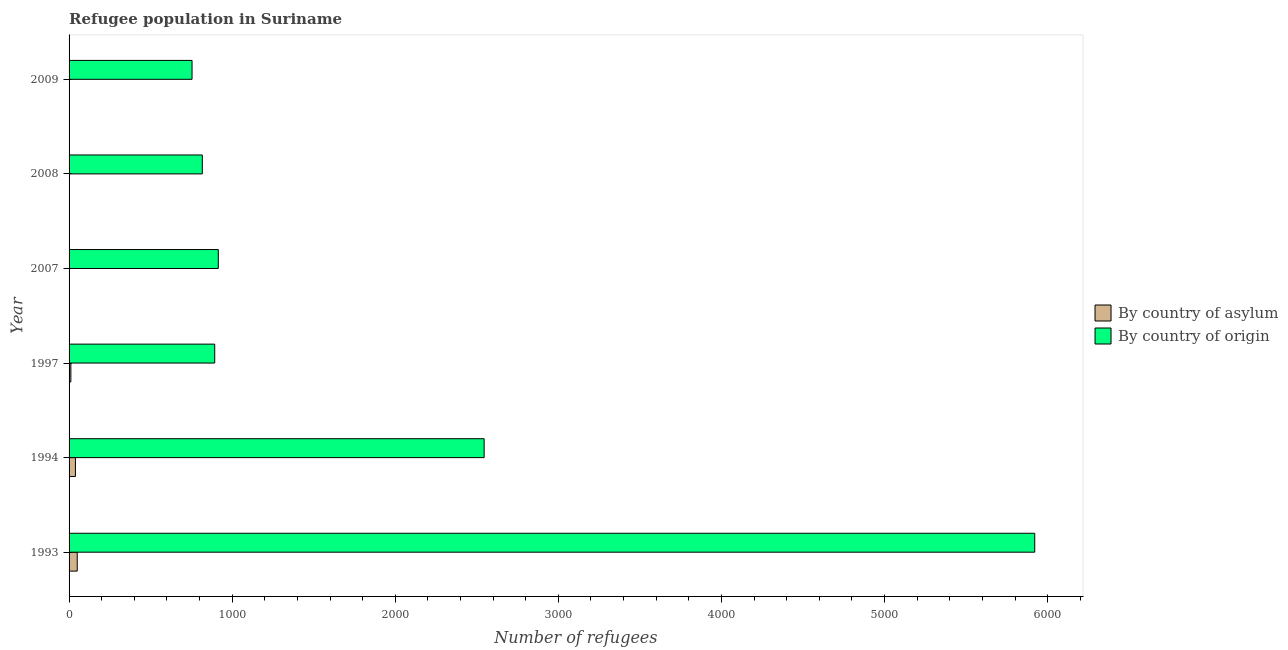Are the number of bars on each tick of the Y-axis equal?
Keep it short and to the point. Yes. How many bars are there on the 4th tick from the bottom?
Provide a short and direct response. 2. What is the label of the 1st group of bars from the top?
Keep it short and to the point. 2009. In how many cases, is the number of bars for a given year not equal to the number of legend labels?
Offer a very short reply. 0. What is the number of refugees by country of asylum in 2007?
Ensure brevity in your answer.  1. Across all years, what is the maximum number of refugees by country of origin?
Keep it short and to the point. 5921. Across all years, what is the minimum number of refugees by country of asylum?
Your answer should be very brief. 1. In which year was the number of refugees by country of asylum minimum?
Make the answer very short. 2007. What is the total number of refugees by country of asylum in the graph?
Your answer should be very brief. 103. What is the difference between the number of refugees by country of asylum in 2007 and that in 2008?
Provide a succinct answer. 0. What is the difference between the number of refugees by country of origin in 1997 and the number of refugees by country of asylum in 1994?
Provide a succinct answer. 854. What is the average number of refugees by country of origin per year?
Ensure brevity in your answer.  1974.17. In the year 1993, what is the difference between the number of refugees by country of asylum and number of refugees by country of origin?
Provide a short and direct response. -5871. In how many years, is the number of refugees by country of origin greater than 1800 ?
Your answer should be very brief. 2. What is the ratio of the number of refugees by country of origin in 2007 to that in 2008?
Offer a very short reply. 1.12. Is the difference between the number of refugees by country of origin in 1994 and 1997 greater than the difference between the number of refugees by country of asylum in 1994 and 1997?
Keep it short and to the point. Yes. What is the difference between the highest and the second highest number of refugees by country of origin?
Make the answer very short. 3376. What is the difference between the highest and the lowest number of refugees by country of asylum?
Offer a very short reply. 49. In how many years, is the number of refugees by country of asylum greater than the average number of refugees by country of asylum taken over all years?
Ensure brevity in your answer.  2. Is the sum of the number of refugees by country of asylum in 1997 and 2009 greater than the maximum number of refugees by country of origin across all years?
Provide a succinct answer. No. What does the 2nd bar from the top in 1997 represents?
Offer a terse response. By country of asylum. What does the 1st bar from the bottom in 2008 represents?
Your response must be concise. By country of asylum. How many bars are there?
Give a very brief answer. 12. Are the values on the major ticks of X-axis written in scientific E-notation?
Provide a short and direct response. No. Does the graph contain any zero values?
Your answer should be very brief. No. How many legend labels are there?
Give a very brief answer. 2. How are the legend labels stacked?
Provide a short and direct response. Vertical. What is the title of the graph?
Your response must be concise. Refugee population in Suriname. What is the label or title of the X-axis?
Provide a short and direct response. Number of refugees. What is the Number of refugees in By country of asylum in 1993?
Give a very brief answer. 50. What is the Number of refugees in By country of origin in 1993?
Make the answer very short. 5921. What is the Number of refugees of By country of origin in 1994?
Give a very brief answer. 2545. What is the Number of refugees in By country of origin in 1997?
Your answer should be very brief. 893. What is the Number of refugees of By country of asylum in 2007?
Provide a short and direct response. 1. What is the Number of refugees in By country of origin in 2007?
Offer a terse response. 915. What is the Number of refugees of By country of origin in 2008?
Offer a very short reply. 817. What is the Number of refugees in By country of asylum in 2009?
Provide a succinct answer. 1. What is the Number of refugees in By country of origin in 2009?
Make the answer very short. 754. Across all years, what is the maximum Number of refugees of By country of origin?
Offer a very short reply. 5921. Across all years, what is the minimum Number of refugees of By country of origin?
Make the answer very short. 754. What is the total Number of refugees in By country of asylum in the graph?
Offer a very short reply. 103. What is the total Number of refugees of By country of origin in the graph?
Provide a succinct answer. 1.18e+04. What is the difference between the Number of refugees in By country of asylum in 1993 and that in 1994?
Provide a short and direct response. 11. What is the difference between the Number of refugees in By country of origin in 1993 and that in 1994?
Provide a succinct answer. 3376. What is the difference between the Number of refugees of By country of origin in 1993 and that in 1997?
Make the answer very short. 5028. What is the difference between the Number of refugees in By country of origin in 1993 and that in 2007?
Your answer should be compact. 5006. What is the difference between the Number of refugees of By country of origin in 1993 and that in 2008?
Your answer should be compact. 5104. What is the difference between the Number of refugees in By country of asylum in 1993 and that in 2009?
Provide a short and direct response. 49. What is the difference between the Number of refugees of By country of origin in 1993 and that in 2009?
Offer a terse response. 5167. What is the difference between the Number of refugees of By country of origin in 1994 and that in 1997?
Offer a very short reply. 1652. What is the difference between the Number of refugees in By country of asylum in 1994 and that in 2007?
Make the answer very short. 38. What is the difference between the Number of refugees of By country of origin in 1994 and that in 2007?
Provide a short and direct response. 1630. What is the difference between the Number of refugees in By country of origin in 1994 and that in 2008?
Make the answer very short. 1728. What is the difference between the Number of refugees of By country of origin in 1994 and that in 2009?
Offer a terse response. 1791. What is the difference between the Number of refugees in By country of asylum in 1997 and that in 2007?
Your answer should be compact. 10. What is the difference between the Number of refugees in By country of origin in 1997 and that in 2008?
Provide a short and direct response. 76. What is the difference between the Number of refugees of By country of asylum in 1997 and that in 2009?
Offer a very short reply. 10. What is the difference between the Number of refugees of By country of origin in 1997 and that in 2009?
Your answer should be very brief. 139. What is the difference between the Number of refugees in By country of asylum in 2007 and that in 2008?
Your response must be concise. 0. What is the difference between the Number of refugees in By country of origin in 2007 and that in 2009?
Ensure brevity in your answer.  161. What is the difference between the Number of refugees in By country of asylum in 2008 and that in 2009?
Offer a terse response. 0. What is the difference between the Number of refugees of By country of origin in 2008 and that in 2009?
Your answer should be compact. 63. What is the difference between the Number of refugees of By country of asylum in 1993 and the Number of refugees of By country of origin in 1994?
Provide a succinct answer. -2495. What is the difference between the Number of refugees of By country of asylum in 1993 and the Number of refugees of By country of origin in 1997?
Provide a succinct answer. -843. What is the difference between the Number of refugees of By country of asylum in 1993 and the Number of refugees of By country of origin in 2007?
Your response must be concise. -865. What is the difference between the Number of refugees in By country of asylum in 1993 and the Number of refugees in By country of origin in 2008?
Give a very brief answer. -767. What is the difference between the Number of refugees in By country of asylum in 1993 and the Number of refugees in By country of origin in 2009?
Your answer should be very brief. -704. What is the difference between the Number of refugees of By country of asylum in 1994 and the Number of refugees of By country of origin in 1997?
Provide a short and direct response. -854. What is the difference between the Number of refugees of By country of asylum in 1994 and the Number of refugees of By country of origin in 2007?
Provide a succinct answer. -876. What is the difference between the Number of refugees in By country of asylum in 1994 and the Number of refugees in By country of origin in 2008?
Provide a short and direct response. -778. What is the difference between the Number of refugees in By country of asylum in 1994 and the Number of refugees in By country of origin in 2009?
Ensure brevity in your answer.  -715. What is the difference between the Number of refugees of By country of asylum in 1997 and the Number of refugees of By country of origin in 2007?
Your response must be concise. -904. What is the difference between the Number of refugees in By country of asylum in 1997 and the Number of refugees in By country of origin in 2008?
Keep it short and to the point. -806. What is the difference between the Number of refugees of By country of asylum in 1997 and the Number of refugees of By country of origin in 2009?
Ensure brevity in your answer.  -743. What is the difference between the Number of refugees of By country of asylum in 2007 and the Number of refugees of By country of origin in 2008?
Your answer should be very brief. -816. What is the difference between the Number of refugees of By country of asylum in 2007 and the Number of refugees of By country of origin in 2009?
Provide a short and direct response. -753. What is the difference between the Number of refugees of By country of asylum in 2008 and the Number of refugees of By country of origin in 2009?
Your response must be concise. -753. What is the average Number of refugees of By country of asylum per year?
Ensure brevity in your answer.  17.17. What is the average Number of refugees in By country of origin per year?
Keep it short and to the point. 1974.17. In the year 1993, what is the difference between the Number of refugees in By country of asylum and Number of refugees in By country of origin?
Offer a terse response. -5871. In the year 1994, what is the difference between the Number of refugees of By country of asylum and Number of refugees of By country of origin?
Your response must be concise. -2506. In the year 1997, what is the difference between the Number of refugees of By country of asylum and Number of refugees of By country of origin?
Your answer should be very brief. -882. In the year 2007, what is the difference between the Number of refugees of By country of asylum and Number of refugees of By country of origin?
Give a very brief answer. -914. In the year 2008, what is the difference between the Number of refugees in By country of asylum and Number of refugees in By country of origin?
Your response must be concise. -816. In the year 2009, what is the difference between the Number of refugees in By country of asylum and Number of refugees in By country of origin?
Provide a succinct answer. -753. What is the ratio of the Number of refugees in By country of asylum in 1993 to that in 1994?
Provide a succinct answer. 1.28. What is the ratio of the Number of refugees in By country of origin in 1993 to that in 1994?
Your response must be concise. 2.33. What is the ratio of the Number of refugees in By country of asylum in 1993 to that in 1997?
Offer a terse response. 4.55. What is the ratio of the Number of refugees of By country of origin in 1993 to that in 1997?
Offer a very short reply. 6.63. What is the ratio of the Number of refugees of By country of origin in 1993 to that in 2007?
Ensure brevity in your answer.  6.47. What is the ratio of the Number of refugees of By country of origin in 1993 to that in 2008?
Offer a very short reply. 7.25. What is the ratio of the Number of refugees in By country of origin in 1993 to that in 2009?
Give a very brief answer. 7.85. What is the ratio of the Number of refugees of By country of asylum in 1994 to that in 1997?
Offer a terse response. 3.55. What is the ratio of the Number of refugees in By country of origin in 1994 to that in 1997?
Give a very brief answer. 2.85. What is the ratio of the Number of refugees of By country of origin in 1994 to that in 2007?
Make the answer very short. 2.78. What is the ratio of the Number of refugees of By country of origin in 1994 to that in 2008?
Make the answer very short. 3.12. What is the ratio of the Number of refugees of By country of asylum in 1994 to that in 2009?
Offer a very short reply. 39. What is the ratio of the Number of refugees of By country of origin in 1994 to that in 2009?
Your response must be concise. 3.38. What is the ratio of the Number of refugees in By country of origin in 1997 to that in 2007?
Offer a very short reply. 0.98. What is the ratio of the Number of refugees of By country of asylum in 1997 to that in 2008?
Offer a terse response. 11. What is the ratio of the Number of refugees in By country of origin in 1997 to that in 2008?
Provide a succinct answer. 1.09. What is the ratio of the Number of refugees of By country of origin in 1997 to that in 2009?
Your answer should be compact. 1.18. What is the ratio of the Number of refugees of By country of asylum in 2007 to that in 2008?
Keep it short and to the point. 1. What is the ratio of the Number of refugees in By country of origin in 2007 to that in 2008?
Give a very brief answer. 1.12. What is the ratio of the Number of refugees of By country of asylum in 2007 to that in 2009?
Keep it short and to the point. 1. What is the ratio of the Number of refugees in By country of origin in 2007 to that in 2009?
Give a very brief answer. 1.21. What is the ratio of the Number of refugees of By country of origin in 2008 to that in 2009?
Your answer should be compact. 1.08. What is the difference between the highest and the second highest Number of refugees in By country of origin?
Provide a succinct answer. 3376. What is the difference between the highest and the lowest Number of refugees of By country of asylum?
Your response must be concise. 49. What is the difference between the highest and the lowest Number of refugees of By country of origin?
Your response must be concise. 5167. 